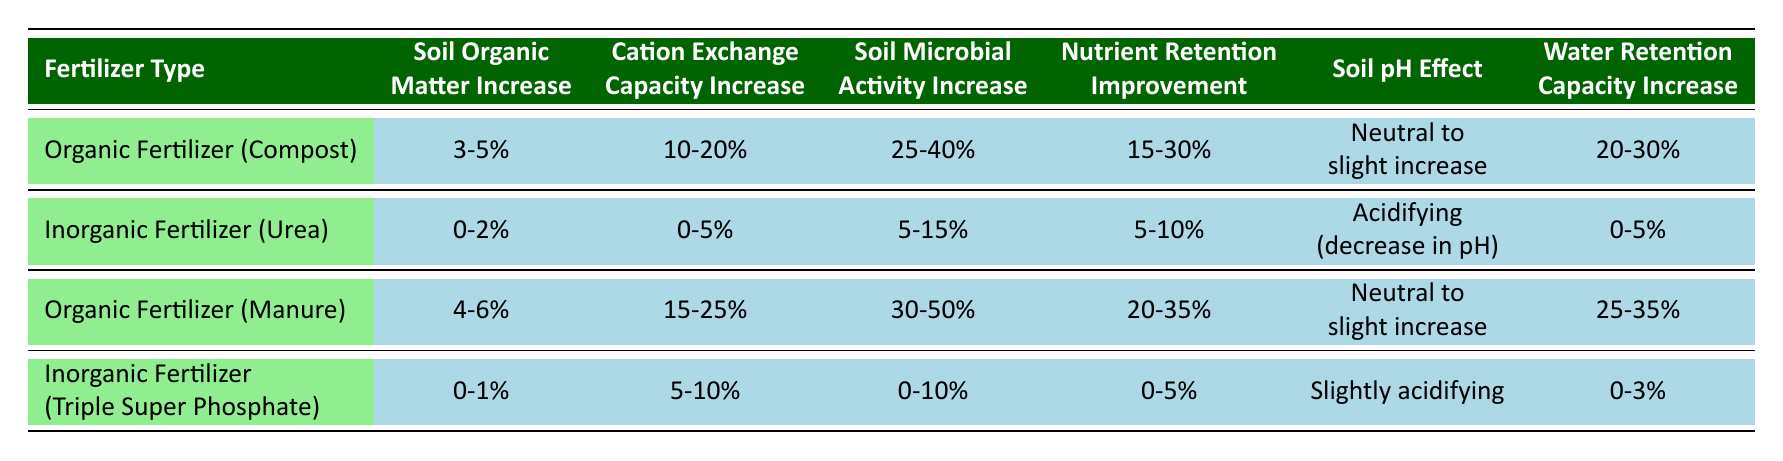What is the effectiveness of organic fertilizer (manure) on soil organic matter increase? The table indicates that organic fertilizer (manure) results in a soil organic matter increase of 4-6%.
Answer: 4-6% Which fertilizer type has the highest increase in soil microbial activity? According to the table, organic fertilizer (manure) shows the highest increase in soil microbial activity, which is 30-50%.
Answer: 30-50% Is the effect of inorganic fertilizer (urea) on soil pH acidifying? The table states that the effect of inorganic fertilizer (urea) is acidifying, leading to a decrease in pH.
Answer: Yes What is the range for the improvement in nutrient retention when using organic fertilizer (compost)? The table shows that using organic fertilizer (compost) leads to a nutrient retention improvement of 15-30%.
Answer: 15-30% Calculate the average increase in cation exchange capacity from both organic fertilizers. For organic fertilizer (compost), the increase is 10-20% and for organic fertilizer (manure) it is 15-25%. The average of the midpoints (15% for compost and 20% for manure) is (15 + 20) / 2 = 17.5%.
Answer: 17.5% Which fertilizer has the least effect on water retention capacity? By examining the table, inorganic fertilizer (triple super phosphate) has the least effect on water retention capacity with an increase of 0-3%.
Answer: 0-3% Does organic fertilizer (compost) improve soil pH? The table indicates that the effect of organic fertilizer (compost) is neutral to a slight increase in pH.
Answer: Yes What is the difference in soil organic matter increase between organic fertilizer (manure) and inorganic fertilizer (urea)? Organic fertilizer (manure) shows a 4-6% increase while inorganic fertilizer (urea) shows a 0-2% increase. The difference is calculated as follows: 6% (manure) - 2% (urea) = 4%.
Answer: 4% Which fertilizer type offers the best improvement in water retention capacity? The table presents that organic fertilizer (manure) offers the best improvement in water retention capacity, with an increase of 25-35%.
Answer: 25-35% 